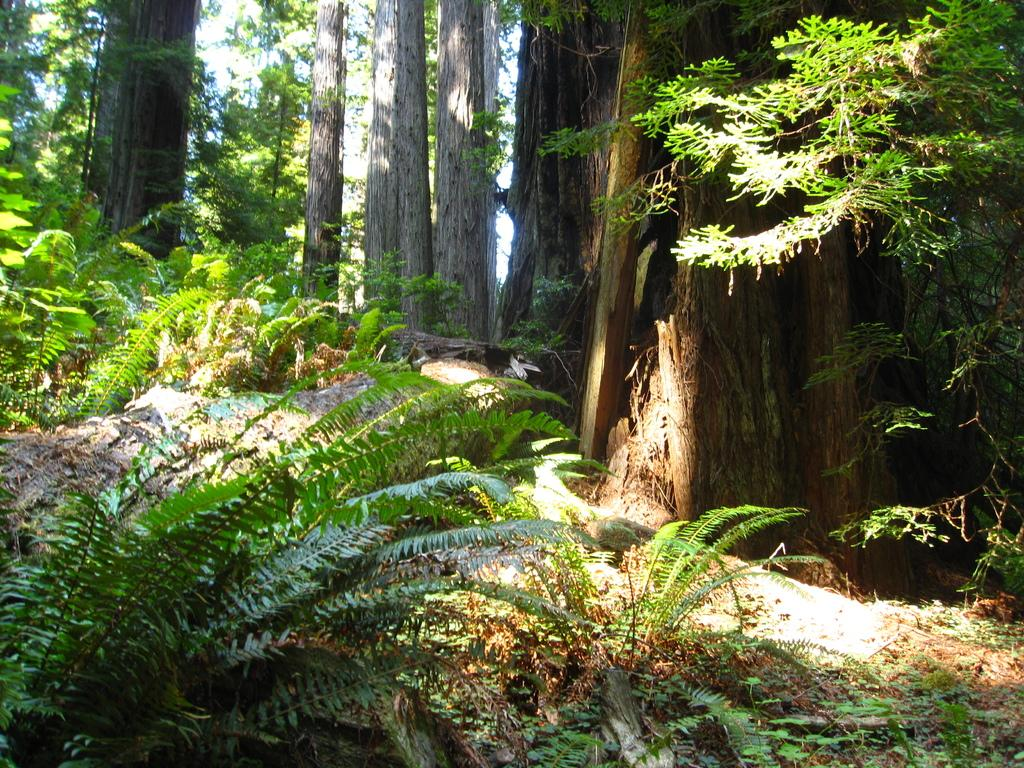What type of vegetation can be seen in the image? There are plants and trees in the image. Can you describe the trees in the image? The trunks of the trees are visible on the ground. How many cows can be seen grazing in the image? There are no cows present in the image; it features plants and trees. 